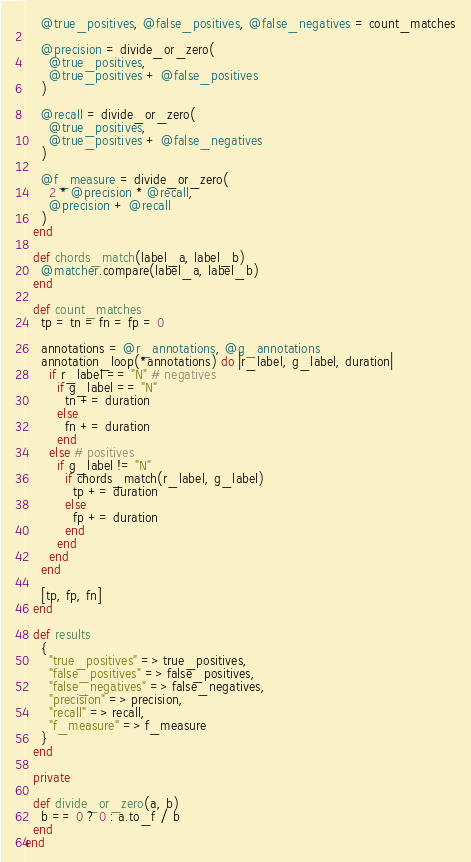<code> <loc_0><loc_0><loc_500><loc_500><_Ruby_>    @true_positives, @false_positives, @false_negatives = count_matches

    @precision = divide_or_zero(
      @true_positives,
      @true_positives + @false_positives
    )

    @recall = divide_or_zero(
      @true_positives,
      @true_positives + @false_negatives
    )

    @f_measure = divide_or_zero(
      2 * @precision * @recall,
      @precision + @recall
    )
  end

  def chords_match(label_a, label_b)
    @matcher.compare(label_a, label_b)
  end

  def count_matches
    tp = tn = fn = fp = 0

    annotations = @r_annotations, @g_annotations
    annotation_loop(*annotations) do |r_label, g_label, duration|
      if r_label == "N" # negatives
        if g_label == "N"
          tn += duration
        else
          fn += duration
        end
      else # positives
        if g_label != "N"
          if chords_match(r_label, g_label)
            tp += duration
          else
            fp += duration
          end
        end
      end
    end

    [tp, fp, fn]
  end

  def results
    {
      "true_positives" => true_positives,
      "false_positives" => false_positives,
      "false_negatives" => false_negatives,
      "precision" => precision,
      "recall" => recall,
      "f_measure" => f_measure
    }
  end

  private

  def divide_or_zero(a, b)
    b == 0 ? 0 : a.to_f / b
  end
end
</code> 